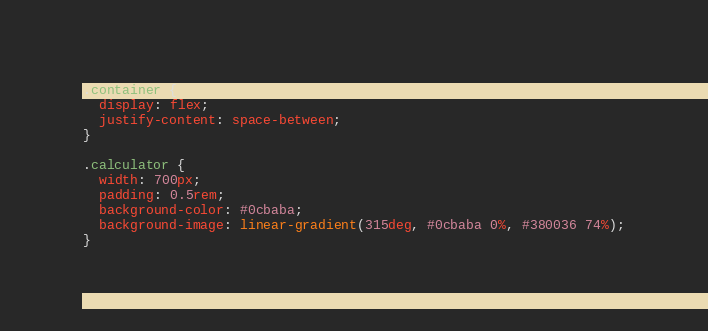Convert code to text. <code><loc_0><loc_0><loc_500><loc_500><_CSS_>.container {
  display: flex;
  justify-content: space-between;
}

.calculator {
  width: 700px;
  padding: 0.5rem;
  background-color: #0cbaba;
  background-image: linear-gradient(315deg, #0cbaba 0%, #380036 74%);
}
</code> 